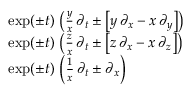<formula> <loc_0><loc_0><loc_500><loc_500>{ \begin{array} { r l } & { \exp ( \pm t ) \, \left ( { \frac { y } { x } } \, \partial _ { t } \pm \left [ y \, \partial _ { x } - x \, \partial _ { y } \right ] \right ) } \\ & { \exp ( \pm t ) \, \left ( { \frac { z } { x } } \, \partial _ { t } \pm \left [ z \, \partial _ { x } - x \, \partial _ { z } \right ] \right ) } \\ & { \exp ( \pm t ) \, \left ( { \frac { 1 } { x } } \, \partial _ { t } \pm \partial _ { x } \right ) } \end{array} }</formula> 